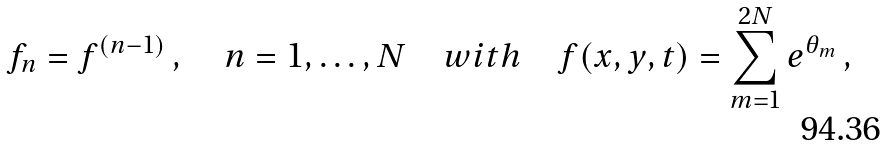Convert formula to latex. <formula><loc_0><loc_0><loc_500><loc_500>f _ { n } = f ^ { ( n - 1 ) } \, , \quad n = 1 , \dots , N \quad w i t h \quad f ( x , y , t ) = \sum _ { m = 1 } ^ { 2 N } e ^ { \theta _ { m } } \, ,</formula> 